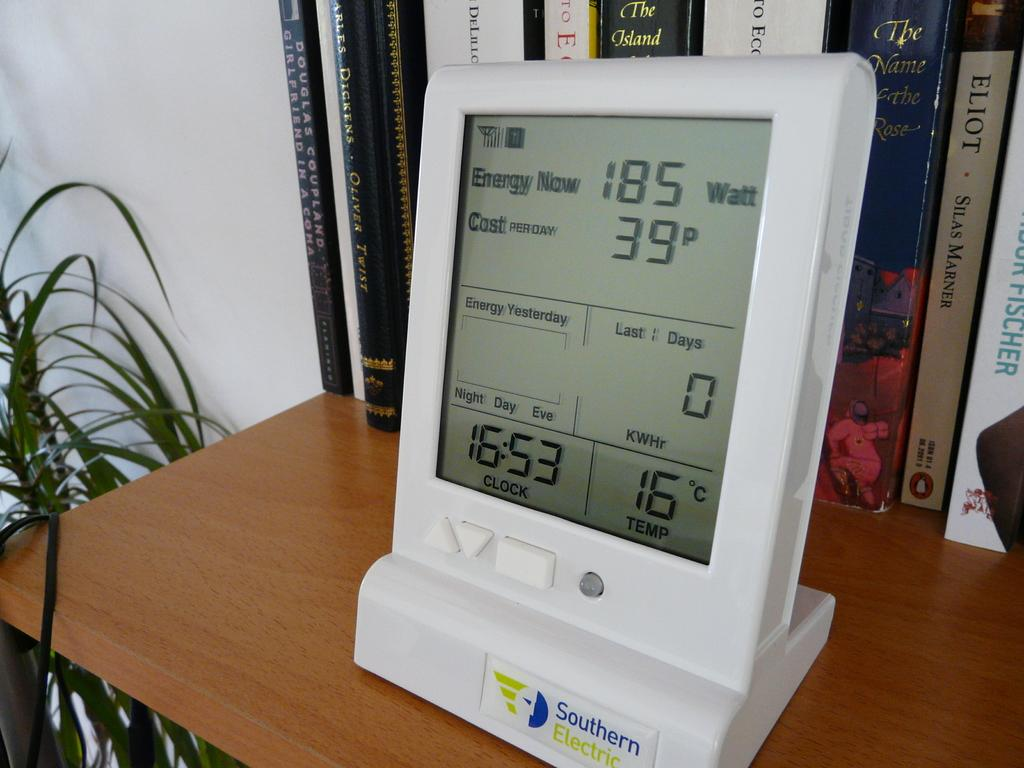<image>
Offer a succinct explanation of the picture presented. According to this device the temperature is 16 degrees celsius. 